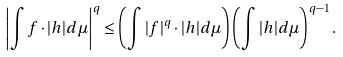<formula> <loc_0><loc_0><loc_500><loc_500>\left | \int f \cdot | h | d \mu \right | ^ { q } \leq \left ( \int | f | ^ { q } \cdot | h | d \mu \right ) \left ( \int | h | d \mu \right ) ^ { q - 1 } .</formula> 